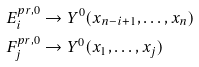Convert formula to latex. <formula><loc_0><loc_0><loc_500><loc_500>& E _ { i } ^ { p r , 0 } \to Y ^ { 0 } ( x _ { n - i + 1 } , \dots , x _ { n } ) \\ & F _ { j } ^ { p r , 0 } \to Y ^ { 0 } ( x _ { 1 } , \dots , x _ { j } )</formula> 